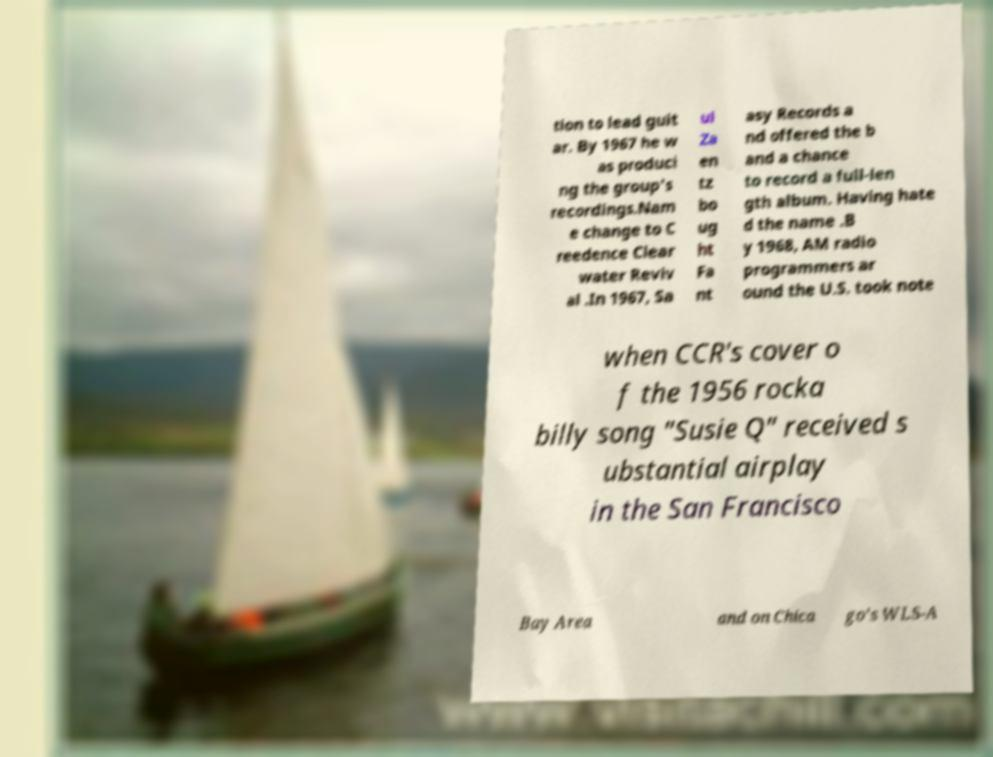There's text embedded in this image that I need extracted. Can you transcribe it verbatim? tion to lead guit ar. By 1967 he w as produci ng the group's recordings.Nam e change to C reedence Clear water Reviv al .In 1967, Sa ul Za en tz bo ug ht Fa nt asy Records a nd offered the b and a chance to record a full-len gth album. Having hate d the name .B y 1968, AM radio programmers ar ound the U.S. took note when CCR's cover o f the 1956 rocka billy song "Susie Q" received s ubstantial airplay in the San Francisco Bay Area and on Chica go's WLS-A 